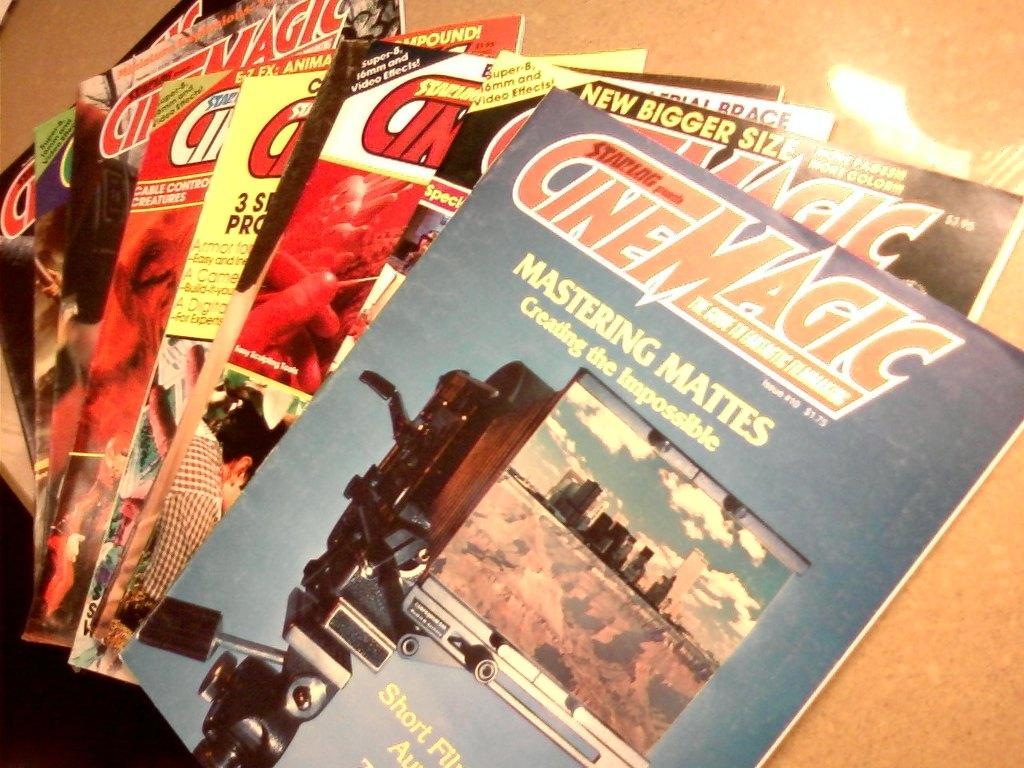<image>
Present a compact description of the photo's key features. a stack of magazines titled 'cinemagic' at the top 